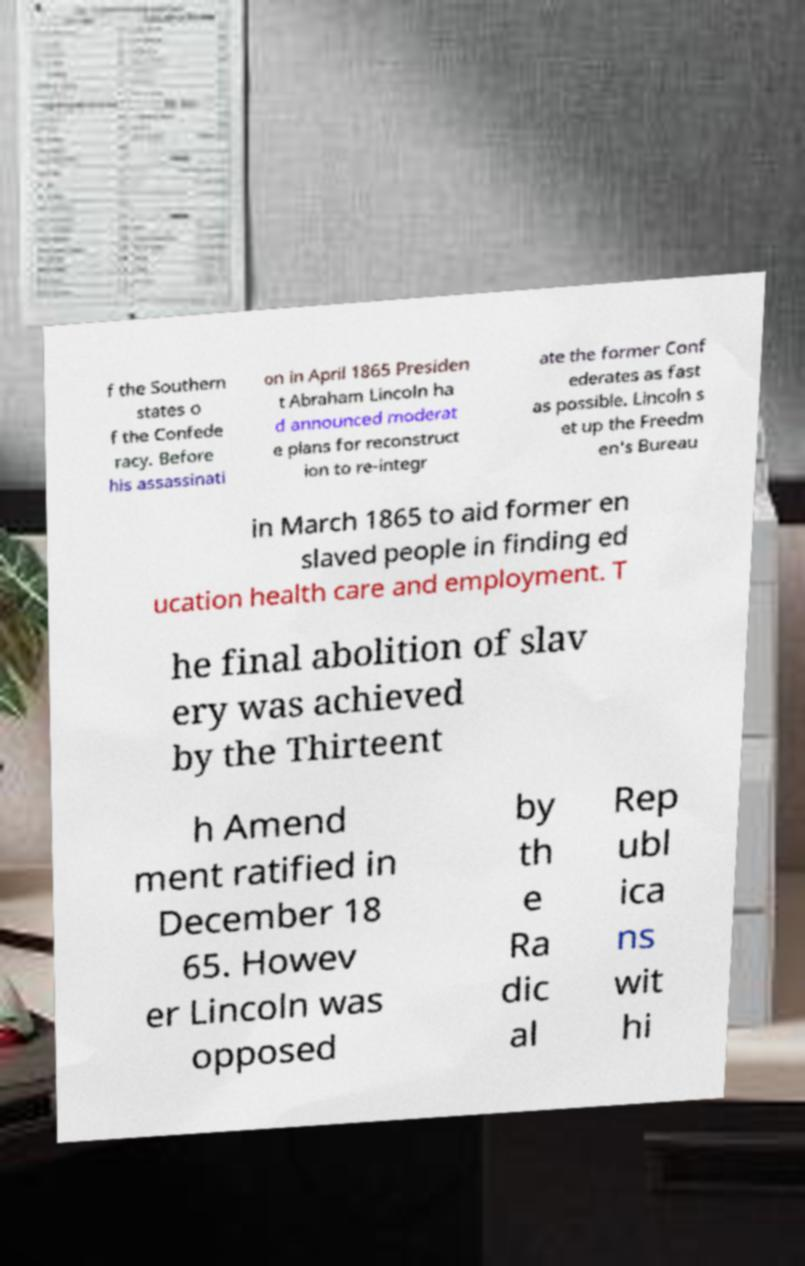Could you extract and type out the text from this image? f the Southern states o f the Confede racy. Before his assassinati on in April 1865 Presiden t Abraham Lincoln ha d announced moderat e plans for reconstruct ion to re-integr ate the former Conf ederates as fast as possible. Lincoln s et up the Freedm en's Bureau in March 1865 to aid former en slaved people in finding ed ucation health care and employment. T he final abolition of slav ery was achieved by the Thirteent h Amend ment ratified in December 18 65. Howev er Lincoln was opposed by th e Ra dic al Rep ubl ica ns wit hi 